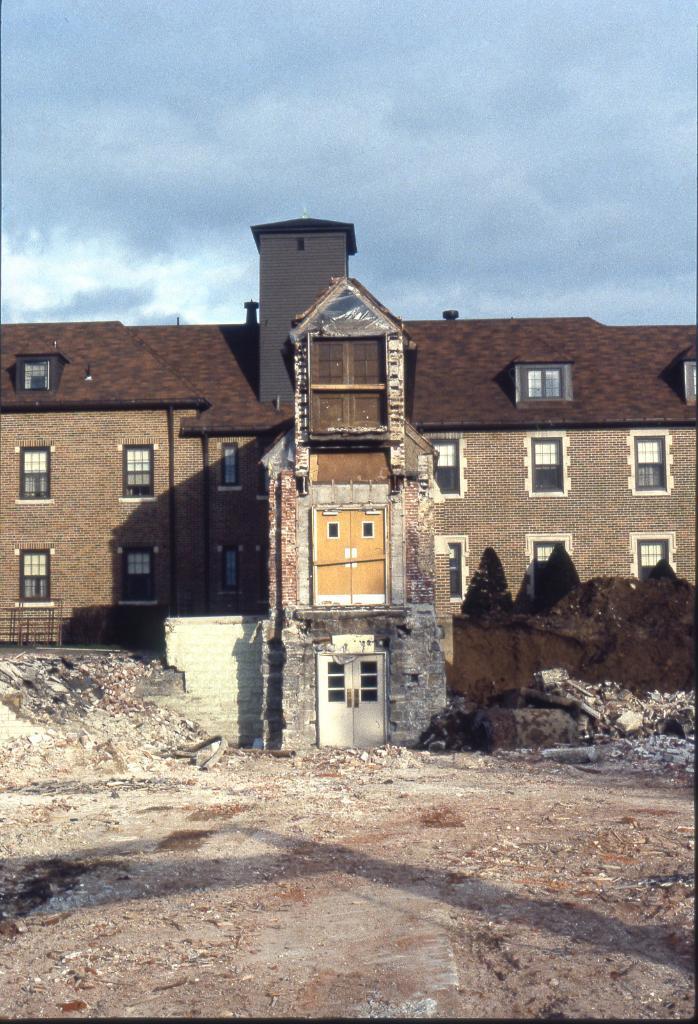Can you describe this image briefly? In this picture we can see one building with some windows and doors. 